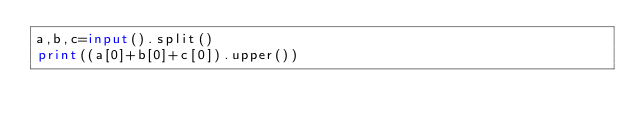Convert code to text. <code><loc_0><loc_0><loc_500><loc_500><_Python_>a,b,c=input().split()
print((a[0]+b[0]+c[0]).upper())

</code> 